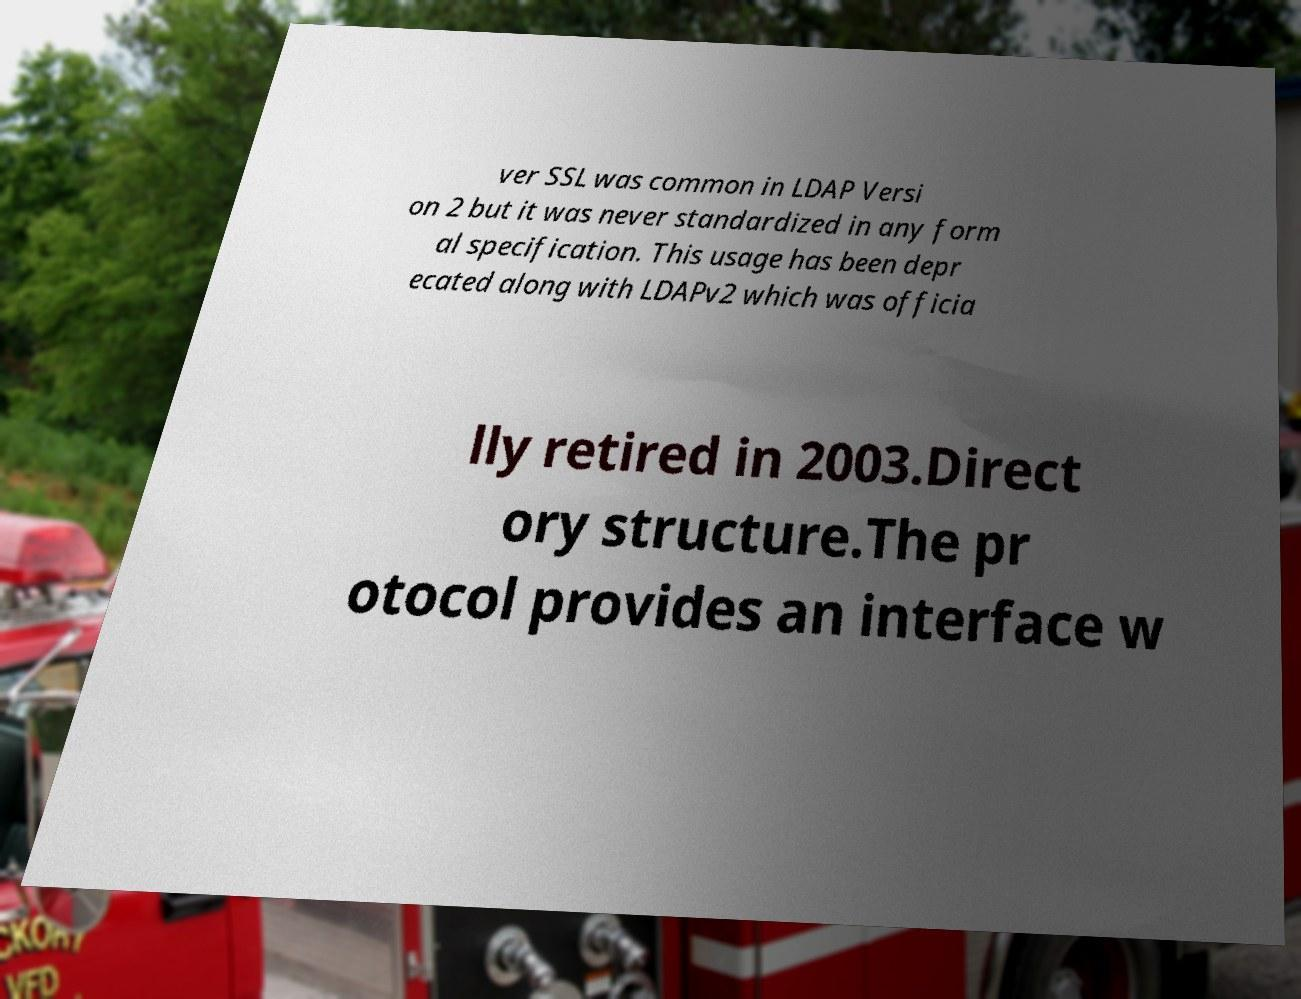Please identify and transcribe the text found in this image. ver SSL was common in LDAP Versi on 2 but it was never standardized in any form al specification. This usage has been depr ecated along with LDAPv2 which was officia lly retired in 2003.Direct ory structure.The pr otocol provides an interface w 